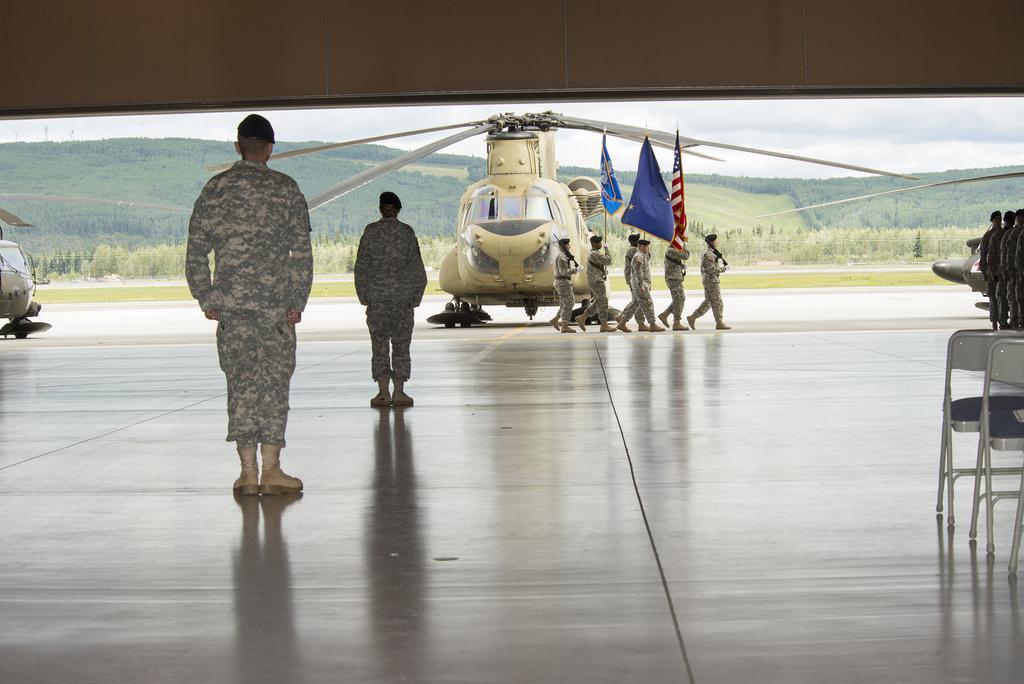How would you summarize this image in a sentence or two? In this picture i can see group of people are standing. On the right side I can see group of people among them few are holding flags. I can also see helicopter, trees and sky. On the right side I can see chairs, people and other objects. 